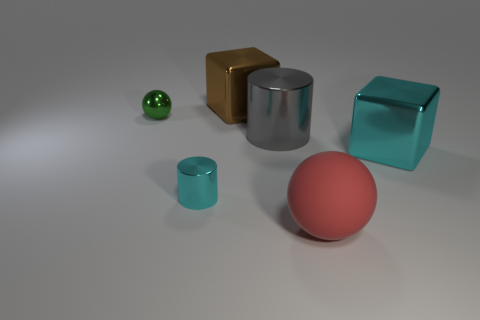What size is the shiny cylinder that is in front of the metal object on the right side of the rubber ball?
Give a very brief answer. Small. There is a metal object that is the same color as the tiny cylinder; what is its shape?
Keep it short and to the point. Cube. How many cylinders are either tiny gray metal things or gray objects?
Make the answer very short. 1. There is a brown thing; does it have the same size as the red sphere that is right of the gray metallic object?
Your answer should be compact. Yes. Are there more balls that are behind the large gray metal cylinder than big cyan metallic cylinders?
Provide a short and direct response. Yes. What size is the green object that is made of the same material as the small cylinder?
Offer a very short reply. Small. Are there any big things that have the same color as the tiny metallic cylinder?
Ensure brevity in your answer.  Yes. What number of objects are tiny red cylinders or cyan things that are behind the cyan cylinder?
Make the answer very short. 1. Are there more large gray metal cylinders than small metal cubes?
Provide a succinct answer. Yes. Is there a gray cylinder made of the same material as the cyan cylinder?
Give a very brief answer. Yes. 